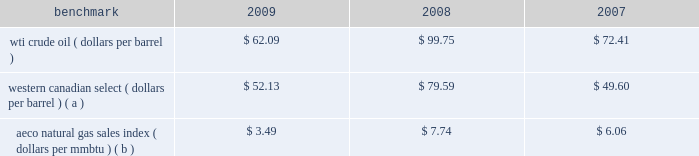Natural gas prices on average were lower in 2009 than in 2008 and in 2007 , with prices in 2008 hitting uniquely high levels .
A significant portion of our natural gas production in the lower 48 states of the u.s .
Is sold at bid-week prices or first-of-month indices relative to our specific producing areas .
A large portion of natural gas sales in alaska are subject to term contracts .
Our other major natural gas-producing regions are europe and equatorial guinea , where large portions of our natural gas sales are also subject to term contracts , making realized prices in these areas less volatile .
As we sell larger quantities of natural gas from these regions , to the extent that these fixed prices are lower than prevailing prices , our reported average natural gas prices realizations may be less than benchmark natural gas prices .
Oil sands mining oil sands mining segment revenues correlate with prevailing market prices for the various qualities of synthetic crude oil and vacuum gas oil we produce .
Roughly two-thirds of the normal output mix will track movements in wti and one-third will track movements in the canadian heavy sour crude oil marker , primarily western canadian select .
Output mix can be impacted by operational problems or planned unit outages at the mine or the upgrader .
The operating cost structure of the oil sands mining operations is predominantly fixed and therefore many of the costs incurred in times of full operation continue during production downtime .
Per-unit costs are sensitive to production rates .
Key variable costs are natural gas and diesel fuel , which track commodity markets such as the canadian aeco natural gas sales index and crude prices respectively .
The table below shows average benchmark prices that impact both our revenues and variable costs. .
Western canadian select ( dollars per barrel ) ( a ) $ 52.13 $ 79.59 $ 49.60 aeco natural gas sales index ( dollars per mmbtu ) ( b ) $ 3.49 $ 7.74 $ 6.06 ( a ) monthly pricing based upon average wti adjusted for differentials unique to western canada .
( b ) alberta energy company day ahead index .
Integrated gas our integrated gas strategy is to link stranded natural gas resources with areas where a supply gap is emerging due to declining production and growing demand .
Our integrated gas operations include marketing and transportation of products manufactured from natural gas , such as lng and methanol , primarily in west africa , the u.s .
And europe .
Our most significant lng investment is our 60 percent ownership in a production facility in equatorial guinea , which sells lng under a long-term contract at prices tied to henry hub natural gas prices .
In 2009 , the gross sales from the plant were 3.9 million metric tonnes , while in 2008 , its first full year of operations , the plant sold 3.4 million metric tonnes .
Industry estimates of 2009 lng trade are approximately 185 million metric tonnes .
More lng production facilities and tankers were under construction in 2009 .
As a result of the sharp worldwide economic downturn in 2008 , continued weak economies are expected to lower natural gas consumption in various countries ; therefore , affecting near-term demand for lng .
Long-term lng supply continues to be in demand as markets seek the benefits of clean burning natural gas .
Market prices for lng are not reported or posted .
In general , lng delivered to the u.s .
Is tied to henry hub prices and will track with changes in u.s .
Natural gas prices , while lng sold in europe and asia is indexed to crude oil prices and will track the movement of those prices .
We own a 45 percent interest in a methanol plant located in equatorial guinea through our investment in ampco .
Gross sales of methanol from the plant totaled 960374 metric tonnes in 2009 and 792794 metric tonnes in 2008 .
Methanol demand has a direct impact on ampco 2019s earnings .
Because global demand for methanol is rather limited , changes in the supply-demand balance can have a significant impact on sales prices .
The 2010 chemical markets associates , inc .
Estimates world demand for methanol in 2009 was 41 million metric tonnes .
Our plant capacity is 1.1 million , or about 3 percent of total demand .
Refining , marketing and transportation rm&t segment income depends largely on our refining and wholesale marketing gross margin , refinery throughputs and retail marketing gross margins for gasoline , distillates and merchandise. .
In 2009 , the gross sales from the plant were 3.9 million metric tonnes . what was the increase from 2008 , its first full year of operations , in million metric tonnes?\\n? 
Computations: (3.9 - 3.4)
Answer: 0.5. 